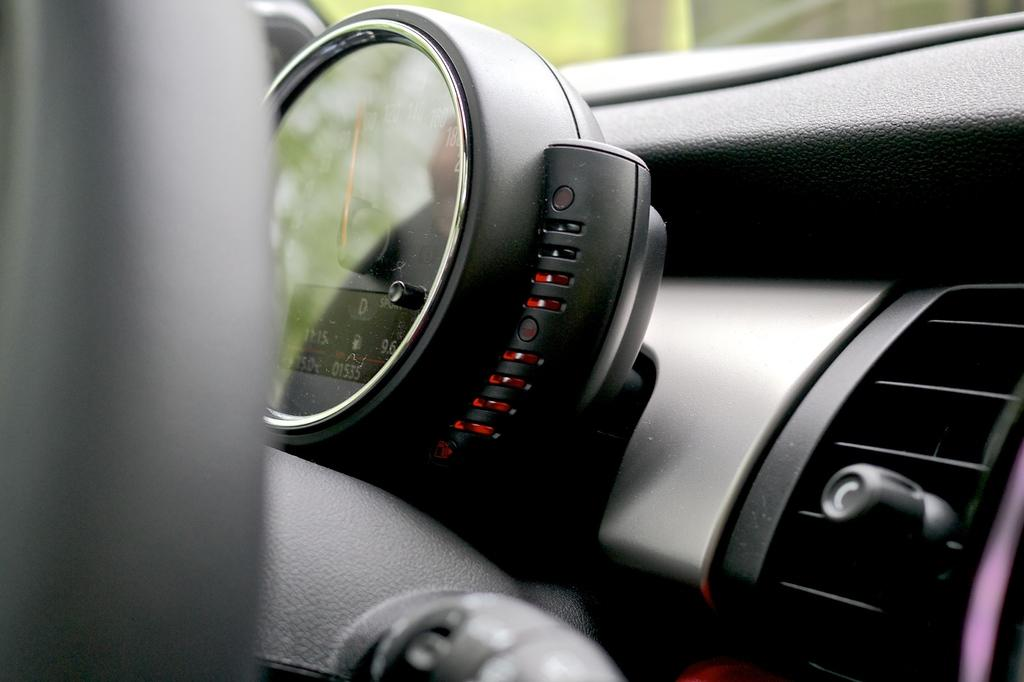What type of setting is depicted in the image? The image is an inside view of a car. What type of prose can be heard being read by the queen in the image? There is no queen or prose present in the image; it is an inside view of a car. 